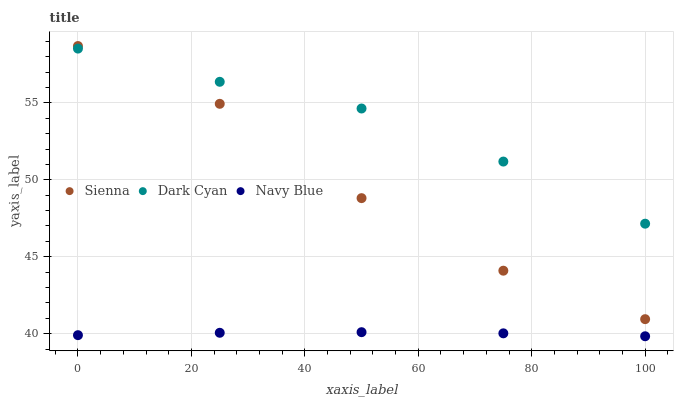Does Navy Blue have the minimum area under the curve?
Answer yes or no. Yes. Does Dark Cyan have the maximum area under the curve?
Answer yes or no. Yes. Does Dark Cyan have the minimum area under the curve?
Answer yes or no. No. Does Navy Blue have the maximum area under the curve?
Answer yes or no. No. Is Navy Blue the smoothest?
Answer yes or no. Yes. Is Sienna the roughest?
Answer yes or no. Yes. Is Dark Cyan the smoothest?
Answer yes or no. No. Is Dark Cyan the roughest?
Answer yes or no. No. Does Navy Blue have the lowest value?
Answer yes or no. Yes. Does Dark Cyan have the lowest value?
Answer yes or no. No. Does Sienna have the highest value?
Answer yes or no. Yes. Does Dark Cyan have the highest value?
Answer yes or no. No. Is Navy Blue less than Sienna?
Answer yes or no. Yes. Is Dark Cyan greater than Navy Blue?
Answer yes or no. Yes. Does Sienna intersect Dark Cyan?
Answer yes or no. Yes. Is Sienna less than Dark Cyan?
Answer yes or no. No. Is Sienna greater than Dark Cyan?
Answer yes or no. No. Does Navy Blue intersect Sienna?
Answer yes or no. No. 